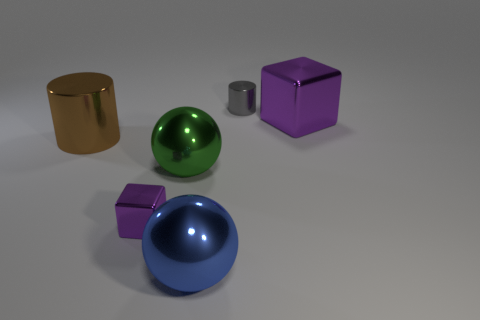What number of cylinders are either small gray objects or green things?
Keep it short and to the point. 1. There is a small block that is the same color as the big block; what is it made of?
Make the answer very short. Metal. Are there fewer big metal cylinders that are behind the large purple thing than purple things to the left of the big cylinder?
Offer a terse response. No. What number of things are either shiny cylinders that are behind the big metal block or green shiny things?
Make the answer very short. 2. There is a big metallic object in front of the large shiny sphere behind the small purple metallic block; what is its shape?
Your response must be concise. Sphere. Are there any purple matte cubes that have the same size as the blue metal object?
Keep it short and to the point. No. Is the number of large shiny spheres greater than the number of small cylinders?
Make the answer very short. Yes. There is a purple metallic object in front of the green metallic object; does it have the same size as the purple metal object behind the small purple shiny block?
Offer a terse response. No. How many metallic things are both to the left of the green object and in front of the large brown cylinder?
Make the answer very short. 1. What color is the other large object that is the same shape as the large blue object?
Offer a very short reply. Green. 